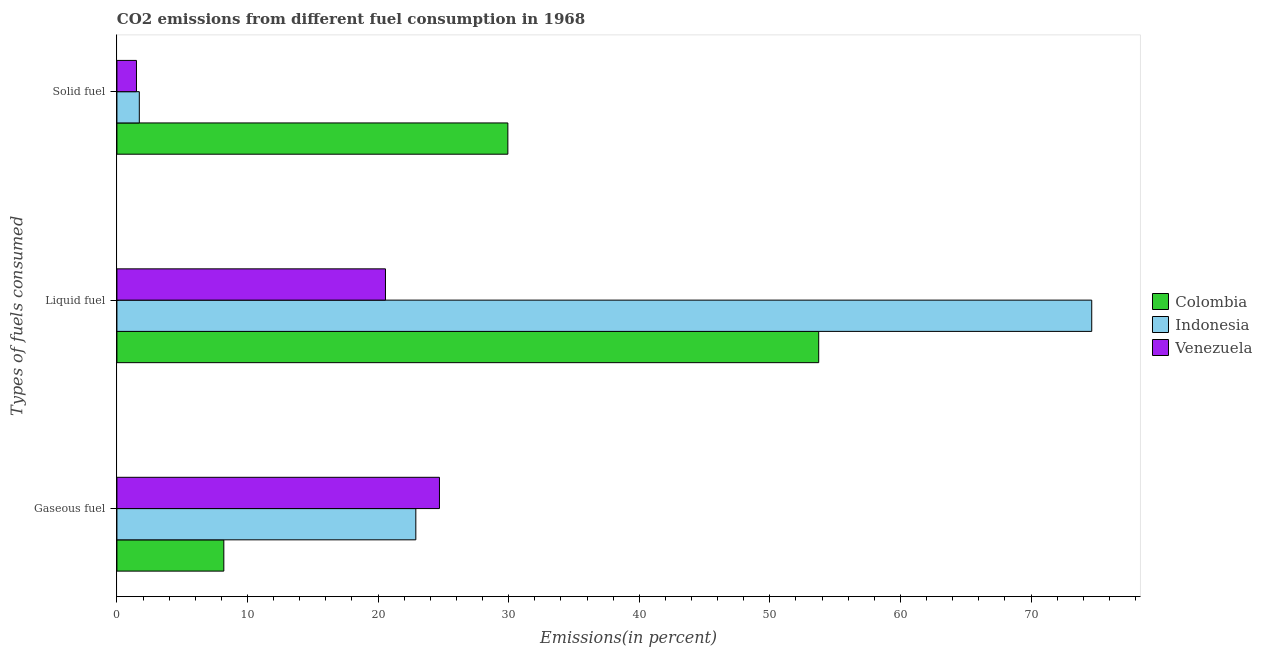How many groups of bars are there?
Your response must be concise. 3. Are the number of bars per tick equal to the number of legend labels?
Give a very brief answer. Yes. What is the label of the 3rd group of bars from the top?
Provide a succinct answer. Gaseous fuel. What is the percentage of gaseous fuel emission in Indonesia?
Your answer should be compact. 22.89. Across all countries, what is the maximum percentage of solid fuel emission?
Your response must be concise. 29.94. Across all countries, what is the minimum percentage of liquid fuel emission?
Your response must be concise. 20.57. In which country was the percentage of solid fuel emission minimum?
Provide a succinct answer. Venezuela. What is the total percentage of liquid fuel emission in the graph?
Provide a succinct answer. 148.96. What is the difference between the percentage of liquid fuel emission in Venezuela and that in Colombia?
Give a very brief answer. -33.18. What is the difference between the percentage of gaseous fuel emission in Indonesia and the percentage of liquid fuel emission in Venezuela?
Make the answer very short. 2.32. What is the average percentage of liquid fuel emission per country?
Your answer should be very brief. 49.65. What is the difference between the percentage of liquid fuel emission and percentage of solid fuel emission in Venezuela?
Offer a very short reply. 19.07. What is the ratio of the percentage of solid fuel emission in Indonesia to that in Venezuela?
Provide a short and direct response. 1.15. What is the difference between the highest and the second highest percentage of liquid fuel emission?
Keep it short and to the point. 20.91. What is the difference between the highest and the lowest percentage of solid fuel emission?
Your answer should be very brief. 28.44. In how many countries, is the percentage of solid fuel emission greater than the average percentage of solid fuel emission taken over all countries?
Provide a short and direct response. 1. What does the 1st bar from the top in Solid fuel represents?
Provide a succinct answer. Venezuela. What does the 3rd bar from the bottom in Liquid fuel represents?
Your answer should be compact. Venezuela. Is it the case that in every country, the sum of the percentage of gaseous fuel emission and percentage of liquid fuel emission is greater than the percentage of solid fuel emission?
Your response must be concise. Yes. How many bars are there?
Your answer should be very brief. 9. Are all the bars in the graph horizontal?
Provide a succinct answer. Yes. Where does the legend appear in the graph?
Keep it short and to the point. Center right. What is the title of the graph?
Ensure brevity in your answer.  CO2 emissions from different fuel consumption in 1968. What is the label or title of the X-axis?
Give a very brief answer. Emissions(in percent). What is the label or title of the Y-axis?
Ensure brevity in your answer.  Types of fuels consumed. What is the Emissions(in percent) of Colombia in Gaseous fuel?
Provide a short and direct response. 8.19. What is the Emissions(in percent) of Indonesia in Gaseous fuel?
Offer a terse response. 22.89. What is the Emissions(in percent) of Venezuela in Gaseous fuel?
Give a very brief answer. 24.7. What is the Emissions(in percent) of Colombia in Liquid fuel?
Give a very brief answer. 53.74. What is the Emissions(in percent) in Indonesia in Liquid fuel?
Offer a very short reply. 74.65. What is the Emissions(in percent) in Venezuela in Liquid fuel?
Provide a succinct answer. 20.57. What is the Emissions(in percent) in Colombia in Solid fuel?
Provide a succinct answer. 29.94. What is the Emissions(in percent) in Indonesia in Solid fuel?
Provide a succinct answer. 1.71. What is the Emissions(in percent) in Venezuela in Solid fuel?
Your answer should be compact. 1.5. Across all Types of fuels consumed, what is the maximum Emissions(in percent) of Colombia?
Your answer should be very brief. 53.74. Across all Types of fuels consumed, what is the maximum Emissions(in percent) in Indonesia?
Make the answer very short. 74.65. Across all Types of fuels consumed, what is the maximum Emissions(in percent) in Venezuela?
Ensure brevity in your answer.  24.7. Across all Types of fuels consumed, what is the minimum Emissions(in percent) in Colombia?
Your answer should be very brief. 8.19. Across all Types of fuels consumed, what is the minimum Emissions(in percent) of Indonesia?
Offer a terse response. 1.71. Across all Types of fuels consumed, what is the minimum Emissions(in percent) of Venezuela?
Offer a terse response. 1.5. What is the total Emissions(in percent) of Colombia in the graph?
Ensure brevity in your answer.  91.87. What is the total Emissions(in percent) in Indonesia in the graph?
Provide a short and direct response. 99.26. What is the total Emissions(in percent) of Venezuela in the graph?
Provide a short and direct response. 46.76. What is the difference between the Emissions(in percent) in Colombia in Gaseous fuel and that in Liquid fuel?
Keep it short and to the point. -45.55. What is the difference between the Emissions(in percent) of Indonesia in Gaseous fuel and that in Liquid fuel?
Provide a short and direct response. -51.76. What is the difference between the Emissions(in percent) of Venezuela in Gaseous fuel and that in Liquid fuel?
Your response must be concise. 4.13. What is the difference between the Emissions(in percent) in Colombia in Gaseous fuel and that in Solid fuel?
Give a very brief answer. -21.75. What is the difference between the Emissions(in percent) of Indonesia in Gaseous fuel and that in Solid fuel?
Ensure brevity in your answer.  21.18. What is the difference between the Emissions(in percent) of Venezuela in Gaseous fuel and that in Solid fuel?
Offer a very short reply. 23.2. What is the difference between the Emissions(in percent) of Colombia in Liquid fuel and that in Solid fuel?
Make the answer very short. 23.8. What is the difference between the Emissions(in percent) of Indonesia in Liquid fuel and that in Solid fuel?
Your response must be concise. 72.94. What is the difference between the Emissions(in percent) of Venezuela in Liquid fuel and that in Solid fuel?
Offer a very short reply. 19.07. What is the difference between the Emissions(in percent) in Colombia in Gaseous fuel and the Emissions(in percent) in Indonesia in Liquid fuel?
Offer a very short reply. -66.46. What is the difference between the Emissions(in percent) in Colombia in Gaseous fuel and the Emissions(in percent) in Venezuela in Liquid fuel?
Offer a terse response. -12.38. What is the difference between the Emissions(in percent) of Indonesia in Gaseous fuel and the Emissions(in percent) of Venezuela in Liquid fuel?
Provide a succinct answer. 2.32. What is the difference between the Emissions(in percent) in Colombia in Gaseous fuel and the Emissions(in percent) in Indonesia in Solid fuel?
Offer a very short reply. 6.47. What is the difference between the Emissions(in percent) of Colombia in Gaseous fuel and the Emissions(in percent) of Venezuela in Solid fuel?
Give a very brief answer. 6.69. What is the difference between the Emissions(in percent) of Indonesia in Gaseous fuel and the Emissions(in percent) of Venezuela in Solid fuel?
Ensure brevity in your answer.  21.39. What is the difference between the Emissions(in percent) in Colombia in Liquid fuel and the Emissions(in percent) in Indonesia in Solid fuel?
Your response must be concise. 52.03. What is the difference between the Emissions(in percent) of Colombia in Liquid fuel and the Emissions(in percent) of Venezuela in Solid fuel?
Keep it short and to the point. 52.24. What is the difference between the Emissions(in percent) of Indonesia in Liquid fuel and the Emissions(in percent) of Venezuela in Solid fuel?
Your answer should be very brief. 73.15. What is the average Emissions(in percent) of Colombia per Types of fuels consumed?
Offer a terse response. 30.62. What is the average Emissions(in percent) of Indonesia per Types of fuels consumed?
Ensure brevity in your answer.  33.09. What is the average Emissions(in percent) of Venezuela per Types of fuels consumed?
Your answer should be compact. 15.59. What is the difference between the Emissions(in percent) in Colombia and Emissions(in percent) in Indonesia in Gaseous fuel?
Your answer should be compact. -14.7. What is the difference between the Emissions(in percent) of Colombia and Emissions(in percent) of Venezuela in Gaseous fuel?
Your answer should be very brief. -16.51. What is the difference between the Emissions(in percent) in Indonesia and Emissions(in percent) in Venezuela in Gaseous fuel?
Your answer should be compact. -1.81. What is the difference between the Emissions(in percent) in Colombia and Emissions(in percent) in Indonesia in Liquid fuel?
Your answer should be compact. -20.91. What is the difference between the Emissions(in percent) of Colombia and Emissions(in percent) of Venezuela in Liquid fuel?
Give a very brief answer. 33.18. What is the difference between the Emissions(in percent) in Indonesia and Emissions(in percent) in Venezuela in Liquid fuel?
Your response must be concise. 54.09. What is the difference between the Emissions(in percent) of Colombia and Emissions(in percent) of Indonesia in Solid fuel?
Ensure brevity in your answer.  28.22. What is the difference between the Emissions(in percent) of Colombia and Emissions(in percent) of Venezuela in Solid fuel?
Keep it short and to the point. 28.44. What is the difference between the Emissions(in percent) of Indonesia and Emissions(in percent) of Venezuela in Solid fuel?
Give a very brief answer. 0.22. What is the ratio of the Emissions(in percent) in Colombia in Gaseous fuel to that in Liquid fuel?
Offer a terse response. 0.15. What is the ratio of the Emissions(in percent) of Indonesia in Gaseous fuel to that in Liquid fuel?
Ensure brevity in your answer.  0.31. What is the ratio of the Emissions(in percent) in Venezuela in Gaseous fuel to that in Liquid fuel?
Provide a short and direct response. 1.2. What is the ratio of the Emissions(in percent) in Colombia in Gaseous fuel to that in Solid fuel?
Make the answer very short. 0.27. What is the ratio of the Emissions(in percent) of Indonesia in Gaseous fuel to that in Solid fuel?
Ensure brevity in your answer.  13.35. What is the ratio of the Emissions(in percent) of Venezuela in Gaseous fuel to that in Solid fuel?
Provide a short and direct response. 16.5. What is the ratio of the Emissions(in percent) of Colombia in Liquid fuel to that in Solid fuel?
Ensure brevity in your answer.  1.8. What is the ratio of the Emissions(in percent) in Indonesia in Liquid fuel to that in Solid fuel?
Offer a terse response. 43.53. What is the ratio of the Emissions(in percent) of Venezuela in Liquid fuel to that in Solid fuel?
Provide a succinct answer. 13.74. What is the difference between the highest and the second highest Emissions(in percent) of Colombia?
Give a very brief answer. 23.8. What is the difference between the highest and the second highest Emissions(in percent) of Indonesia?
Offer a very short reply. 51.76. What is the difference between the highest and the second highest Emissions(in percent) in Venezuela?
Offer a terse response. 4.13. What is the difference between the highest and the lowest Emissions(in percent) of Colombia?
Your answer should be very brief. 45.55. What is the difference between the highest and the lowest Emissions(in percent) of Indonesia?
Ensure brevity in your answer.  72.94. What is the difference between the highest and the lowest Emissions(in percent) of Venezuela?
Ensure brevity in your answer.  23.2. 